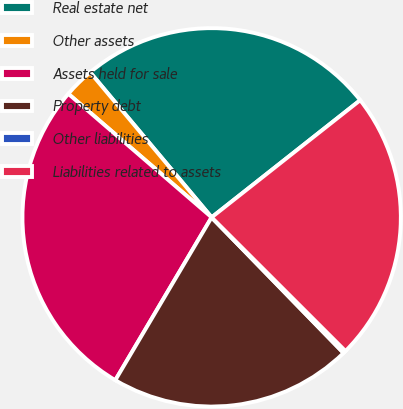<chart> <loc_0><loc_0><loc_500><loc_500><pie_chart><fcel>Real estate net<fcel>Other assets<fcel>Assets held for sale<fcel>Property debt<fcel>Other liabilities<fcel>Liabilities related to assets<nl><fcel>25.47%<fcel>2.58%<fcel>27.82%<fcel>20.78%<fcel>0.23%<fcel>23.12%<nl></chart> 